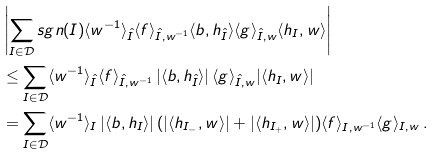Convert formula to latex. <formula><loc_0><loc_0><loc_500><loc_500>& \left | \sum _ { I \in \mathcal { D } } s g n ( I ) \langle w ^ { - 1 } \rangle _ { \hat { I } } \langle f \rangle _ { \hat { I } , w ^ { - 1 } } \langle b , h _ { \hat { I } } \rangle \langle g \rangle _ { \hat { I } , w } \langle h _ { I } , w \rangle \right | \\ & \leq \sum _ { I \in \mathcal { D } } \langle w ^ { - 1 } \rangle _ { \hat { I } } \langle f \rangle _ { \hat { I } , w ^ { - 1 } } \, | \langle b , h _ { \hat { I } } \rangle | \, \langle g \rangle _ { \hat { I } , w } | \langle h _ { I } , w \rangle | \\ & = \sum _ { I \in \mathcal { D } } \langle w ^ { - 1 } \rangle _ { I } \, | \langle b , h _ { I } \rangle | \, ( | \langle h _ { I _ { - } } , w \rangle | + | \langle h _ { I _ { + } } , w \rangle | ) \langle f \rangle _ { I , w ^ { - 1 } } \langle g \rangle _ { I , w } \, .</formula> 